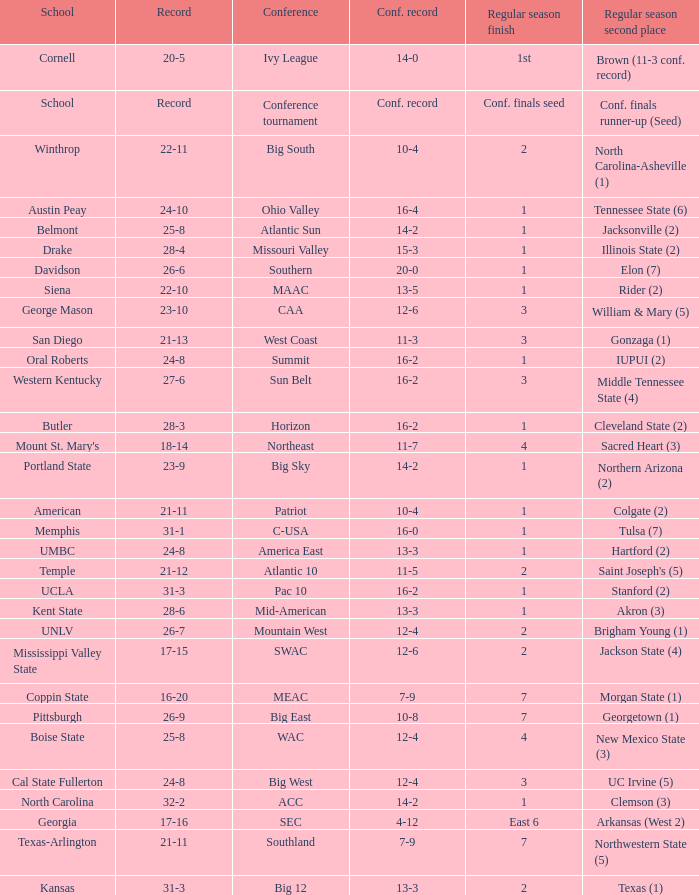What was the cumulative record of oral roberts college? 24-8. 